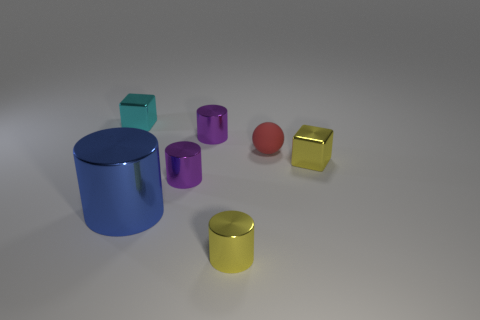Add 1 shiny cylinders. How many objects exist? 8 Subtract all tiny yellow cylinders. How many cylinders are left? 3 Subtract 1 blocks. How many blocks are left? 1 Subtract all yellow cylinders. How many cylinders are left? 3 Subtract all cylinders. How many objects are left? 3 Add 2 blue metal cylinders. How many blue metal cylinders are left? 3 Add 5 big blue objects. How many big blue objects exist? 6 Subtract 0 green balls. How many objects are left? 7 Subtract all brown cubes. Subtract all cyan spheres. How many cubes are left? 2 Subtract all purple cylinders. How many cyan cubes are left? 1 